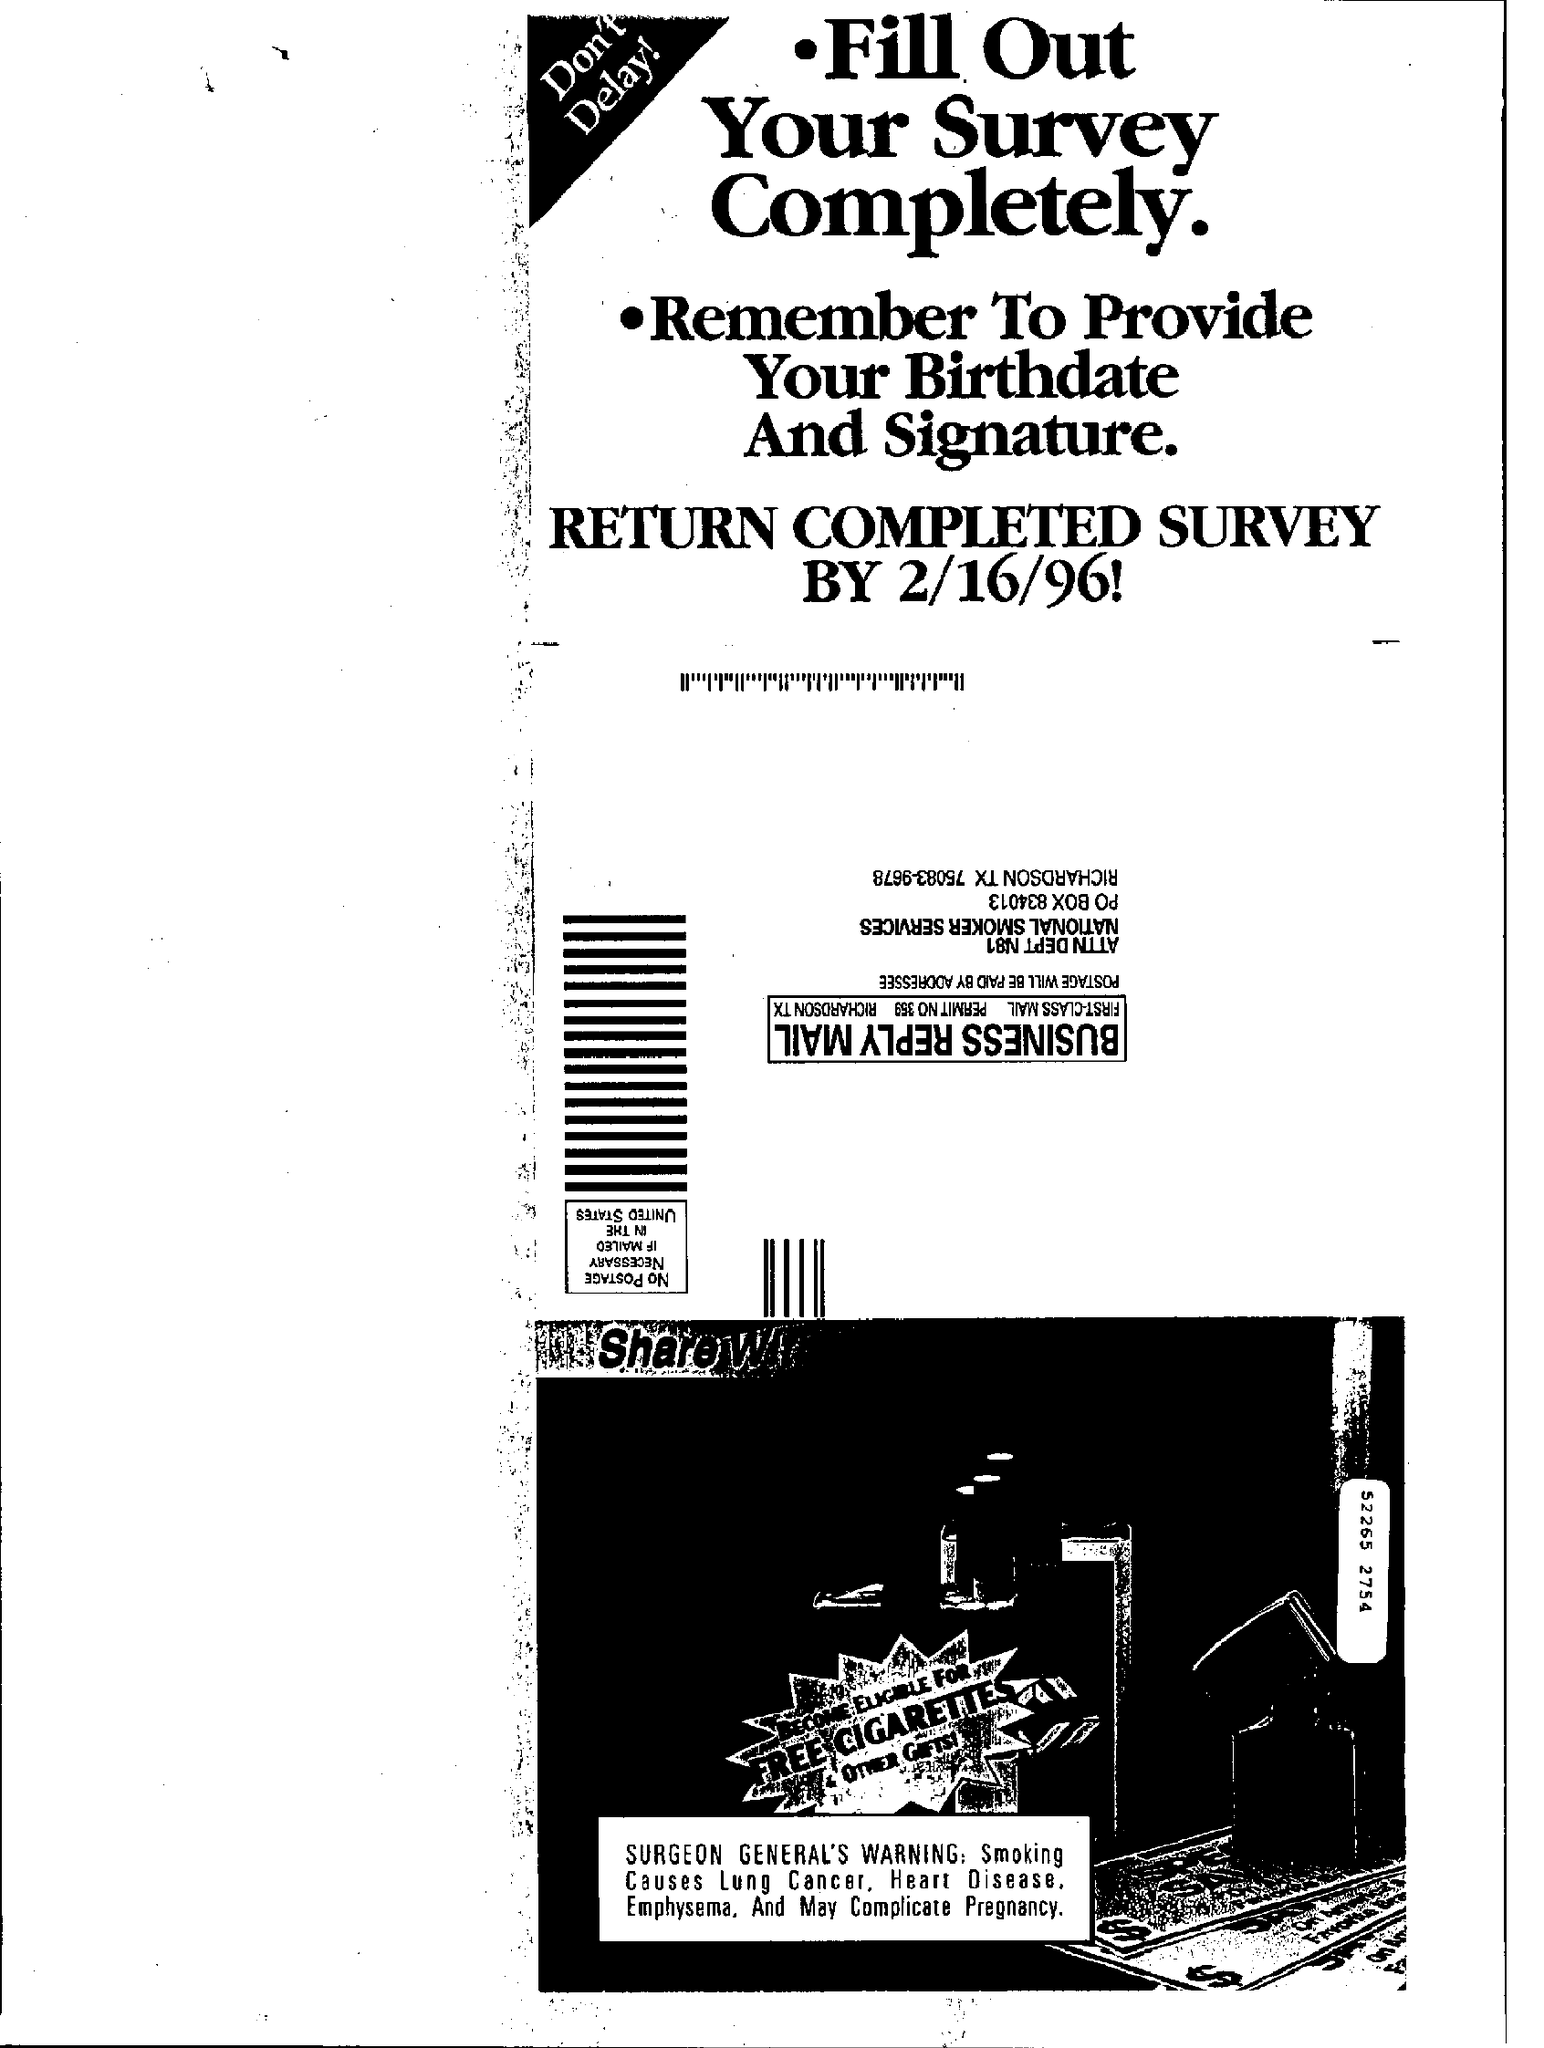When should the Completed survey be returned by?
Offer a terse response. 2/16/96. What should be provided?
Offer a very short reply. Birthdate and Signature. 